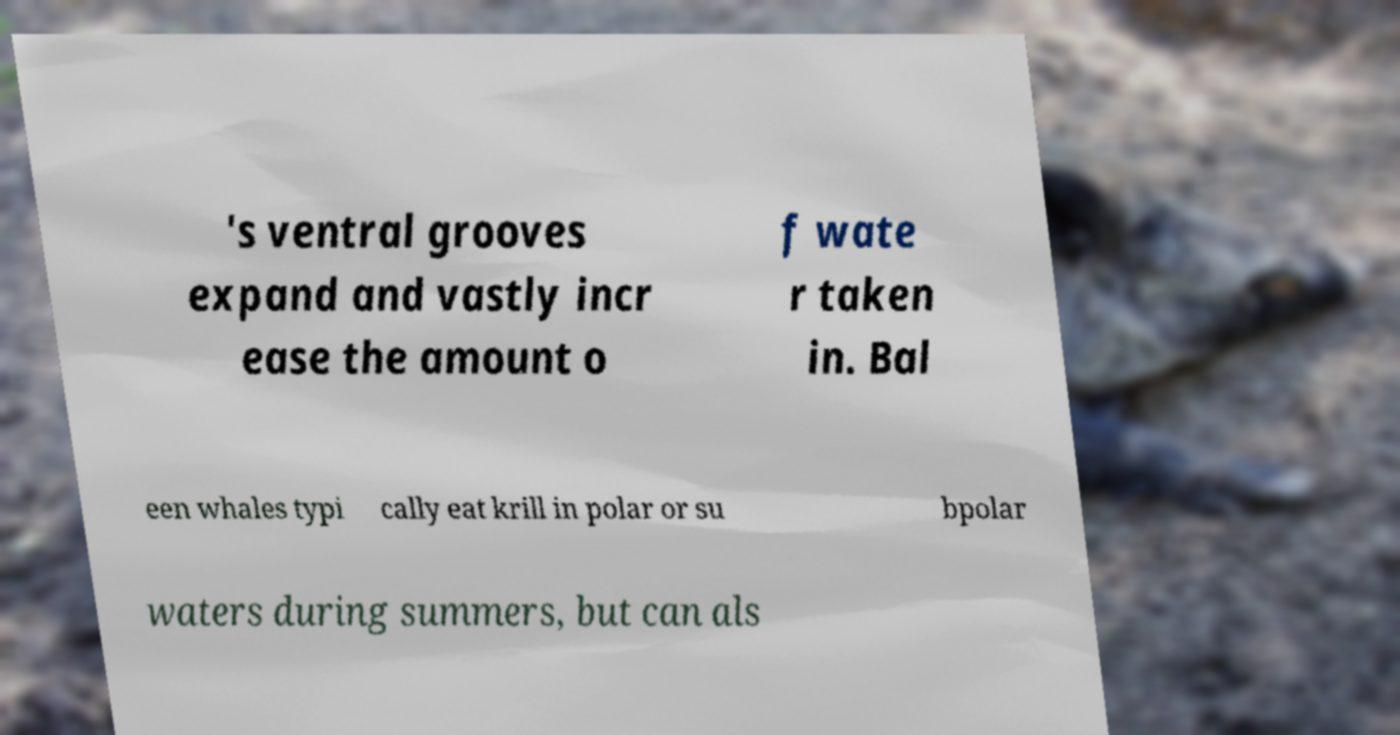I need the written content from this picture converted into text. Can you do that? 's ventral grooves expand and vastly incr ease the amount o f wate r taken in. Bal een whales typi cally eat krill in polar or su bpolar waters during summers, but can als 